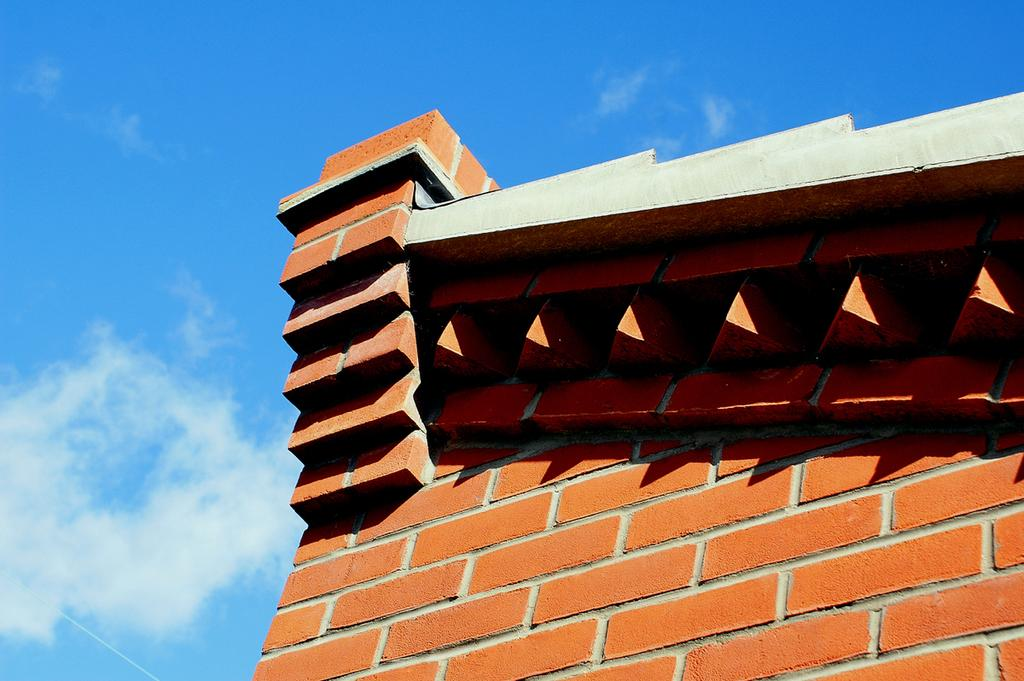What type of structure is visible in the image? There is a brick wall in the image. What can be seen in the background of the image? The sky is visible in the background of the image. How many police officers are standing next to the brick wall in the image? There are no police officers present in the image; it only features a brick wall and the sky in the background. What type of animal is sitting on top of the cub in the image? There is no cub or animal present in the image. 